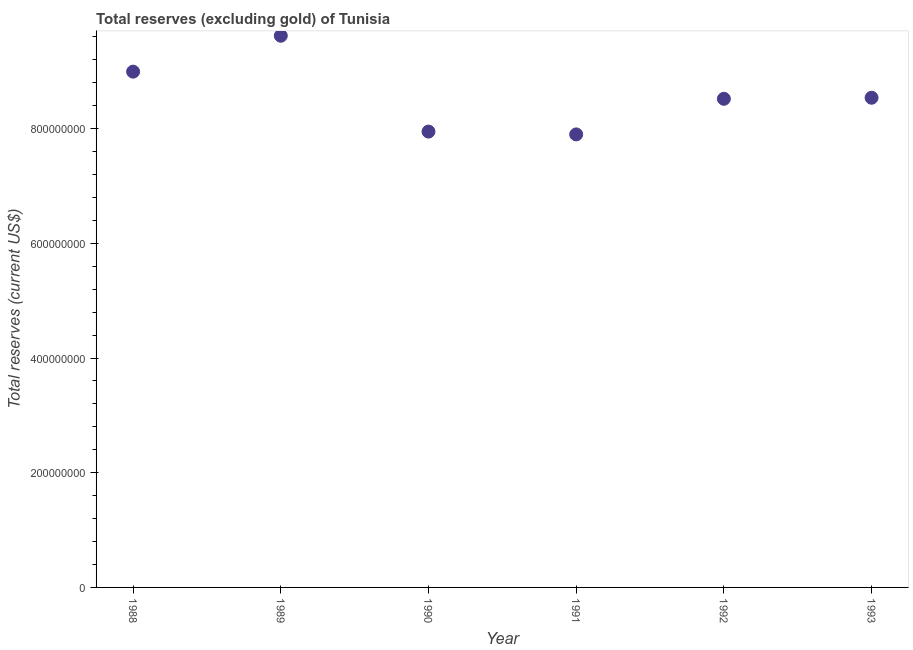What is the total reserves (excluding gold) in 1990?
Ensure brevity in your answer.  7.95e+08. Across all years, what is the maximum total reserves (excluding gold)?
Give a very brief answer. 9.62e+08. Across all years, what is the minimum total reserves (excluding gold)?
Make the answer very short. 7.90e+08. In which year was the total reserves (excluding gold) minimum?
Your answer should be compact. 1991. What is the sum of the total reserves (excluding gold)?
Provide a short and direct response. 5.15e+09. What is the difference between the total reserves (excluding gold) in 1989 and 1990?
Give a very brief answer. 1.67e+08. What is the average total reserves (excluding gold) per year?
Offer a very short reply. 8.59e+08. What is the median total reserves (excluding gold)?
Keep it short and to the point. 8.53e+08. In how many years, is the total reserves (excluding gold) greater than 160000000 US$?
Provide a succinct answer. 6. Do a majority of the years between 1992 and 1989 (inclusive) have total reserves (excluding gold) greater than 880000000 US$?
Offer a very short reply. Yes. What is the ratio of the total reserves (excluding gold) in 1991 to that in 1993?
Provide a succinct answer. 0.93. What is the difference between the highest and the second highest total reserves (excluding gold)?
Keep it short and to the point. 6.26e+07. Is the sum of the total reserves (excluding gold) in 1989 and 1991 greater than the maximum total reserves (excluding gold) across all years?
Your answer should be very brief. Yes. What is the difference between the highest and the lowest total reserves (excluding gold)?
Make the answer very short. 1.72e+08. What is the difference between two consecutive major ticks on the Y-axis?
Offer a terse response. 2.00e+08. Are the values on the major ticks of Y-axis written in scientific E-notation?
Your answer should be compact. No. What is the title of the graph?
Offer a terse response. Total reserves (excluding gold) of Tunisia. What is the label or title of the Y-axis?
Keep it short and to the point. Total reserves (current US$). What is the Total reserves (current US$) in 1988?
Give a very brief answer. 8.99e+08. What is the Total reserves (current US$) in 1989?
Provide a succinct answer. 9.62e+08. What is the Total reserves (current US$) in 1990?
Your answer should be very brief. 7.95e+08. What is the Total reserves (current US$) in 1991?
Offer a very short reply. 7.90e+08. What is the Total reserves (current US$) in 1992?
Your answer should be compact. 8.52e+08. What is the Total reserves (current US$) in 1993?
Keep it short and to the point. 8.54e+08. What is the difference between the Total reserves (current US$) in 1988 and 1989?
Keep it short and to the point. -6.26e+07. What is the difference between the Total reserves (current US$) in 1988 and 1990?
Provide a succinct answer. 1.04e+08. What is the difference between the Total reserves (current US$) in 1988 and 1991?
Your response must be concise. 1.09e+08. What is the difference between the Total reserves (current US$) in 1988 and 1992?
Offer a very short reply. 4.73e+07. What is the difference between the Total reserves (current US$) in 1988 and 1993?
Offer a terse response. 4.55e+07. What is the difference between the Total reserves (current US$) in 1989 and 1990?
Your answer should be very brief. 1.67e+08. What is the difference between the Total reserves (current US$) in 1989 and 1991?
Your answer should be very brief. 1.72e+08. What is the difference between the Total reserves (current US$) in 1989 and 1992?
Your response must be concise. 1.10e+08. What is the difference between the Total reserves (current US$) in 1989 and 1993?
Provide a succinct answer. 1.08e+08. What is the difference between the Total reserves (current US$) in 1990 and 1991?
Ensure brevity in your answer.  4.90e+06. What is the difference between the Total reserves (current US$) in 1990 and 1992?
Your answer should be compact. -5.72e+07. What is the difference between the Total reserves (current US$) in 1990 and 1993?
Provide a succinct answer. -5.90e+07. What is the difference between the Total reserves (current US$) in 1991 and 1992?
Make the answer very short. -6.21e+07. What is the difference between the Total reserves (current US$) in 1991 and 1993?
Your response must be concise. -6.39e+07. What is the difference between the Total reserves (current US$) in 1992 and 1993?
Provide a succinct answer. -1.85e+06. What is the ratio of the Total reserves (current US$) in 1988 to that in 1989?
Keep it short and to the point. 0.94. What is the ratio of the Total reserves (current US$) in 1988 to that in 1990?
Provide a short and direct response. 1.13. What is the ratio of the Total reserves (current US$) in 1988 to that in 1991?
Your answer should be compact. 1.14. What is the ratio of the Total reserves (current US$) in 1988 to that in 1992?
Offer a very short reply. 1.06. What is the ratio of the Total reserves (current US$) in 1988 to that in 1993?
Ensure brevity in your answer.  1.05. What is the ratio of the Total reserves (current US$) in 1989 to that in 1990?
Your response must be concise. 1.21. What is the ratio of the Total reserves (current US$) in 1989 to that in 1991?
Offer a terse response. 1.22. What is the ratio of the Total reserves (current US$) in 1989 to that in 1992?
Offer a terse response. 1.13. What is the ratio of the Total reserves (current US$) in 1989 to that in 1993?
Provide a succinct answer. 1.13. What is the ratio of the Total reserves (current US$) in 1990 to that in 1991?
Provide a succinct answer. 1.01. What is the ratio of the Total reserves (current US$) in 1990 to that in 1992?
Ensure brevity in your answer.  0.93. What is the ratio of the Total reserves (current US$) in 1991 to that in 1992?
Provide a short and direct response. 0.93. What is the ratio of the Total reserves (current US$) in 1991 to that in 1993?
Ensure brevity in your answer.  0.93. 